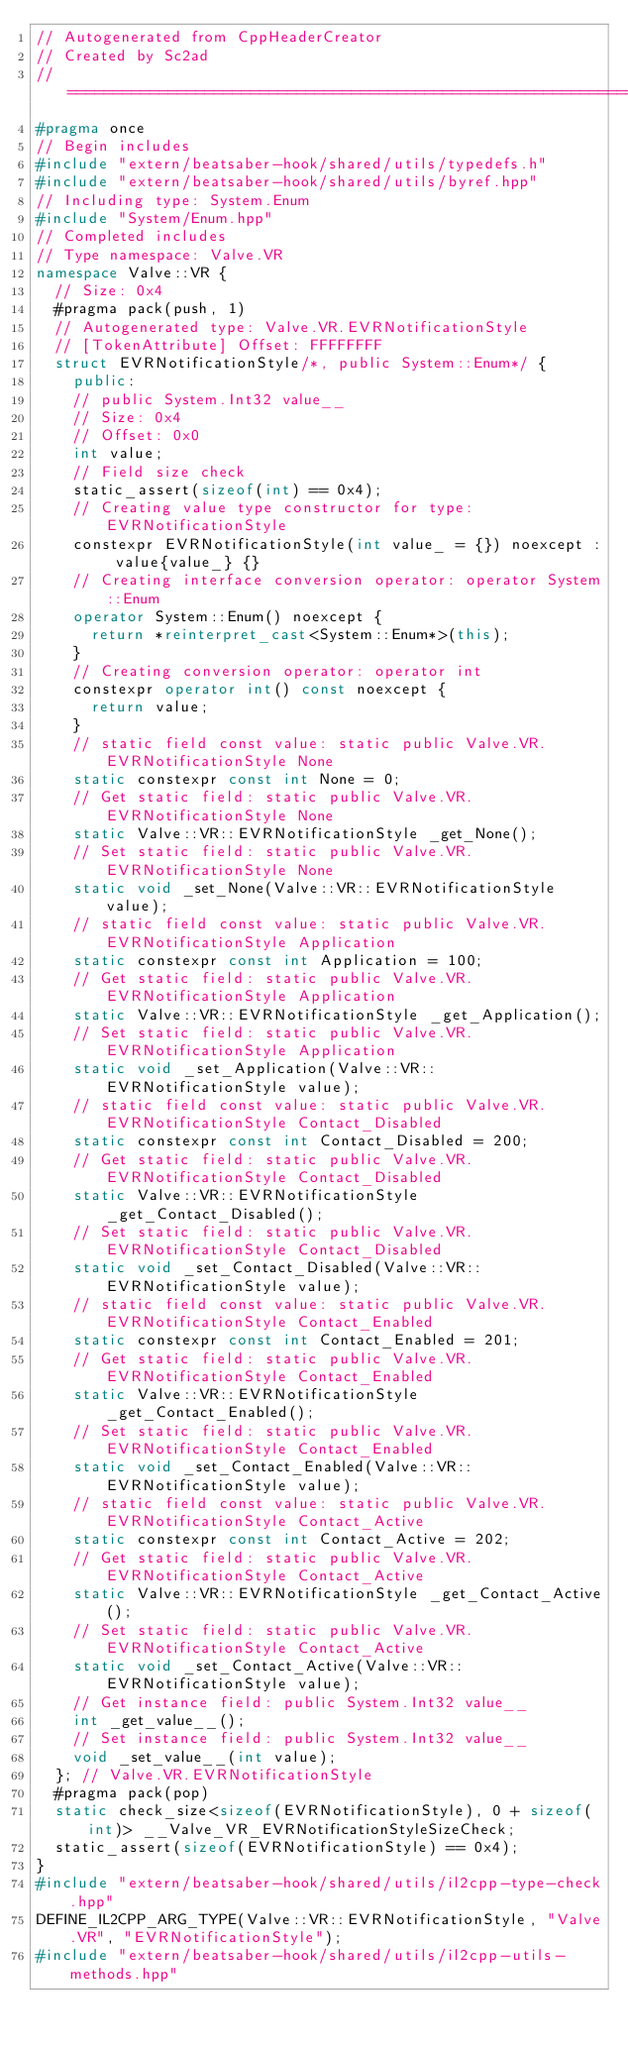<code> <loc_0><loc_0><loc_500><loc_500><_C++_>// Autogenerated from CppHeaderCreator
// Created by Sc2ad
// =========================================================================
#pragma once
// Begin includes
#include "extern/beatsaber-hook/shared/utils/typedefs.h"
#include "extern/beatsaber-hook/shared/utils/byref.hpp"
// Including type: System.Enum
#include "System/Enum.hpp"
// Completed includes
// Type namespace: Valve.VR
namespace Valve::VR {
  // Size: 0x4
  #pragma pack(push, 1)
  // Autogenerated type: Valve.VR.EVRNotificationStyle
  // [TokenAttribute] Offset: FFFFFFFF
  struct EVRNotificationStyle/*, public System::Enum*/ {
    public:
    // public System.Int32 value__
    // Size: 0x4
    // Offset: 0x0
    int value;
    // Field size check
    static_assert(sizeof(int) == 0x4);
    // Creating value type constructor for type: EVRNotificationStyle
    constexpr EVRNotificationStyle(int value_ = {}) noexcept : value{value_} {}
    // Creating interface conversion operator: operator System::Enum
    operator System::Enum() noexcept {
      return *reinterpret_cast<System::Enum*>(this);
    }
    // Creating conversion operator: operator int
    constexpr operator int() const noexcept {
      return value;
    }
    // static field const value: static public Valve.VR.EVRNotificationStyle None
    static constexpr const int None = 0;
    // Get static field: static public Valve.VR.EVRNotificationStyle None
    static Valve::VR::EVRNotificationStyle _get_None();
    // Set static field: static public Valve.VR.EVRNotificationStyle None
    static void _set_None(Valve::VR::EVRNotificationStyle value);
    // static field const value: static public Valve.VR.EVRNotificationStyle Application
    static constexpr const int Application = 100;
    // Get static field: static public Valve.VR.EVRNotificationStyle Application
    static Valve::VR::EVRNotificationStyle _get_Application();
    // Set static field: static public Valve.VR.EVRNotificationStyle Application
    static void _set_Application(Valve::VR::EVRNotificationStyle value);
    // static field const value: static public Valve.VR.EVRNotificationStyle Contact_Disabled
    static constexpr const int Contact_Disabled = 200;
    // Get static field: static public Valve.VR.EVRNotificationStyle Contact_Disabled
    static Valve::VR::EVRNotificationStyle _get_Contact_Disabled();
    // Set static field: static public Valve.VR.EVRNotificationStyle Contact_Disabled
    static void _set_Contact_Disabled(Valve::VR::EVRNotificationStyle value);
    // static field const value: static public Valve.VR.EVRNotificationStyle Contact_Enabled
    static constexpr const int Contact_Enabled = 201;
    // Get static field: static public Valve.VR.EVRNotificationStyle Contact_Enabled
    static Valve::VR::EVRNotificationStyle _get_Contact_Enabled();
    // Set static field: static public Valve.VR.EVRNotificationStyle Contact_Enabled
    static void _set_Contact_Enabled(Valve::VR::EVRNotificationStyle value);
    // static field const value: static public Valve.VR.EVRNotificationStyle Contact_Active
    static constexpr const int Contact_Active = 202;
    // Get static field: static public Valve.VR.EVRNotificationStyle Contact_Active
    static Valve::VR::EVRNotificationStyle _get_Contact_Active();
    // Set static field: static public Valve.VR.EVRNotificationStyle Contact_Active
    static void _set_Contact_Active(Valve::VR::EVRNotificationStyle value);
    // Get instance field: public System.Int32 value__
    int _get_value__();
    // Set instance field: public System.Int32 value__
    void _set_value__(int value);
  }; // Valve.VR.EVRNotificationStyle
  #pragma pack(pop)
  static check_size<sizeof(EVRNotificationStyle), 0 + sizeof(int)> __Valve_VR_EVRNotificationStyleSizeCheck;
  static_assert(sizeof(EVRNotificationStyle) == 0x4);
}
#include "extern/beatsaber-hook/shared/utils/il2cpp-type-check.hpp"
DEFINE_IL2CPP_ARG_TYPE(Valve::VR::EVRNotificationStyle, "Valve.VR", "EVRNotificationStyle");
#include "extern/beatsaber-hook/shared/utils/il2cpp-utils-methods.hpp"
</code> 